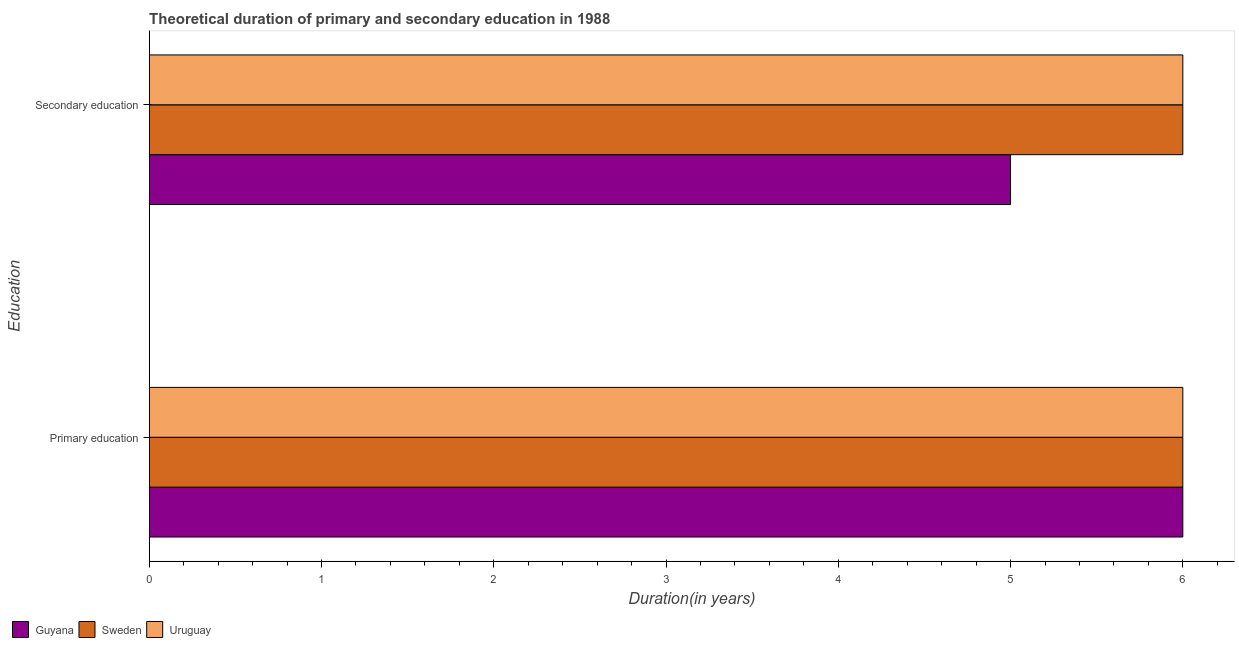How many bars are there on the 1st tick from the top?
Offer a very short reply. 3. How many bars are there on the 2nd tick from the bottom?
Provide a succinct answer. 3. What is the label of the 1st group of bars from the top?
Offer a terse response. Secondary education. What is the duration of secondary education in Sweden?
Offer a terse response. 6. Across all countries, what is the maximum duration of secondary education?
Provide a short and direct response. 6. Across all countries, what is the minimum duration of secondary education?
Provide a short and direct response. 5. In which country was the duration of secondary education minimum?
Make the answer very short. Guyana. What is the total duration of primary education in the graph?
Offer a very short reply. 18. What is the difference between the duration of secondary education in Sweden and that in Guyana?
Offer a very short reply. 1. What is the difference between the duration of secondary education in Sweden and the duration of primary education in Guyana?
Your answer should be very brief. 0. What is the average duration of secondary education per country?
Your answer should be very brief. 5.67. What is the difference between the duration of secondary education and duration of primary education in Guyana?
Ensure brevity in your answer.  -1. In how many countries, is the duration of primary education greater than the average duration of primary education taken over all countries?
Provide a succinct answer. 0. What does the 2nd bar from the top in Primary education represents?
Your answer should be very brief. Sweden. What does the 1st bar from the bottom in Secondary education represents?
Offer a terse response. Guyana. How many bars are there?
Provide a succinct answer. 6. Are all the bars in the graph horizontal?
Ensure brevity in your answer.  Yes. How many countries are there in the graph?
Provide a succinct answer. 3. Does the graph contain grids?
Your answer should be compact. No. Where does the legend appear in the graph?
Your answer should be very brief. Bottom left. How many legend labels are there?
Offer a terse response. 3. What is the title of the graph?
Your response must be concise. Theoretical duration of primary and secondary education in 1988. What is the label or title of the X-axis?
Provide a succinct answer. Duration(in years). What is the label or title of the Y-axis?
Offer a very short reply. Education. What is the Duration(in years) of Sweden in Primary education?
Offer a very short reply. 6. What is the Duration(in years) in Uruguay in Primary education?
Provide a short and direct response. 6. What is the Duration(in years) in Sweden in Secondary education?
Keep it short and to the point. 6. Across all Education, what is the maximum Duration(in years) in Guyana?
Make the answer very short. 6. Across all Education, what is the maximum Duration(in years) in Sweden?
Keep it short and to the point. 6. Across all Education, what is the minimum Duration(in years) in Sweden?
Give a very brief answer. 6. Across all Education, what is the minimum Duration(in years) of Uruguay?
Make the answer very short. 6. What is the total Duration(in years) in Sweden in the graph?
Offer a terse response. 12. What is the difference between the Duration(in years) of Guyana in Primary education and that in Secondary education?
Your response must be concise. 1. What is the difference between the Duration(in years) in Uruguay in Primary education and that in Secondary education?
Your response must be concise. 0. What is the difference between the Duration(in years) in Guyana in Primary education and the Duration(in years) in Sweden in Secondary education?
Keep it short and to the point. 0. What is the difference between the Duration(in years) in Guyana in Primary education and the Duration(in years) in Uruguay in Secondary education?
Your response must be concise. 0. What is the average Duration(in years) in Guyana per Education?
Offer a very short reply. 5.5. What is the average Duration(in years) in Sweden per Education?
Offer a very short reply. 6. What is the difference between the Duration(in years) in Guyana and Duration(in years) in Sweden in Primary education?
Your answer should be very brief. 0. What is the difference between the Duration(in years) in Guyana and Duration(in years) in Uruguay in Primary education?
Make the answer very short. 0. What is the difference between the Duration(in years) of Sweden and Duration(in years) of Uruguay in Primary education?
Provide a short and direct response. 0. 